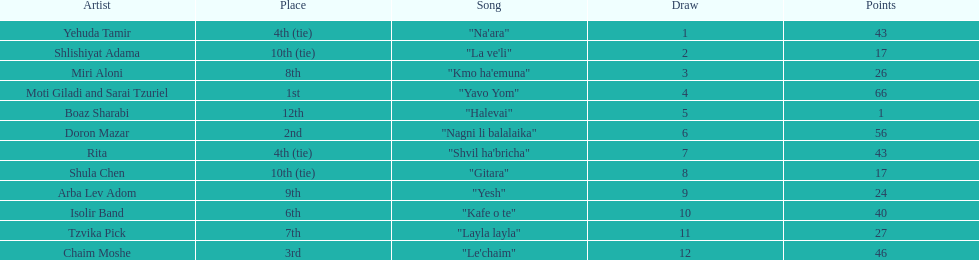Doron mazar, which artist(s) had the most points? Moti Giladi and Sarai Tzuriel. 